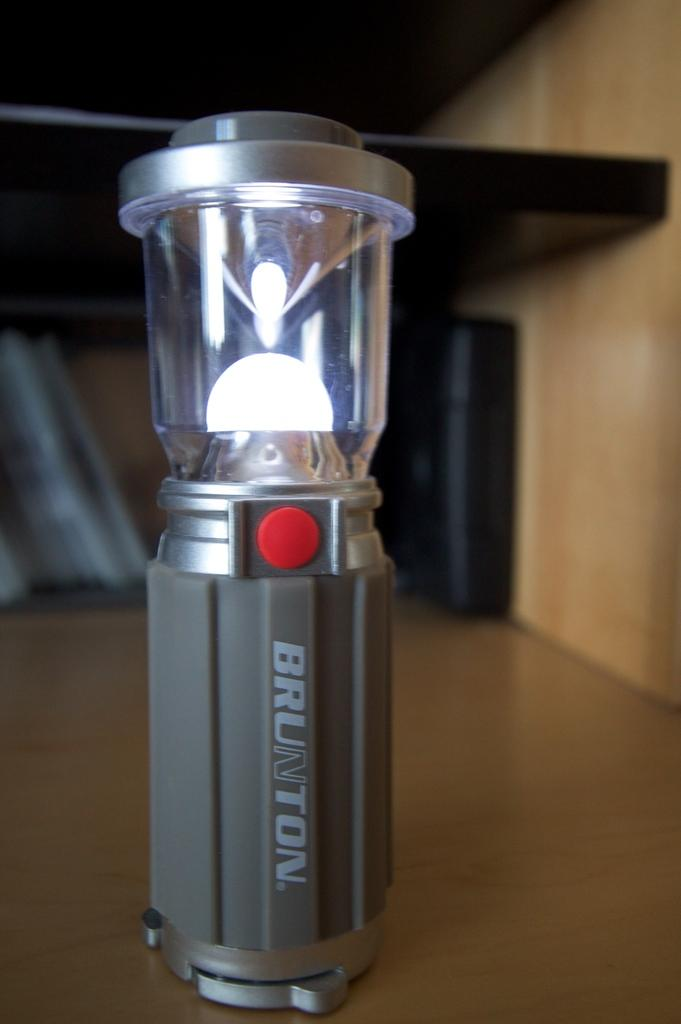<image>
Provide a brief description of the given image. A short bright camping lantern is made by the Brunton company. 